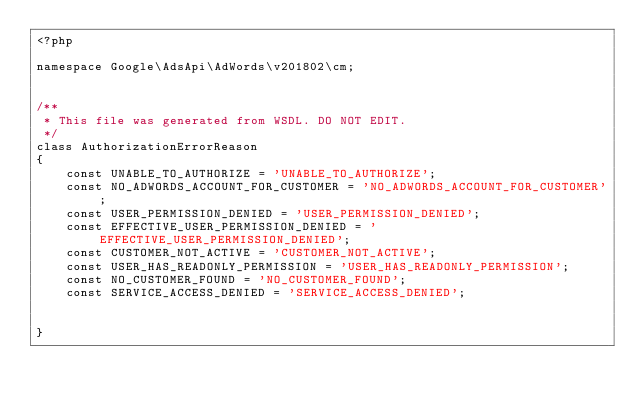<code> <loc_0><loc_0><loc_500><loc_500><_PHP_><?php

namespace Google\AdsApi\AdWords\v201802\cm;


/**
 * This file was generated from WSDL. DO NOT EDIT.
 */
class AuthorizationErrorReason
{
    const UNABLE_TO_AUTHORIZE = 'UNABLE_TO_AUTHORIZE';
    const NO_ADWORDS_ACCOUNT_FOR_CUSTOMER = 'NO_ADWORDS_ACCOUNT_FOR_CUSTOMER';
    const USER_PERMISSION_DENIED = 'USER_PERMISSION_DENIED';
    const EFFECTIVE_USER_PERMISSION_DENIED = 'EFFECTIVE_USER_PERMISSION_DENIED';
    const CUSTOMER_NOT_ACTIVE = 'CUSTOMER_NOT_ACTIVE';
    const USER_HAS_READONLY_PERMISSION = 'USER_HAS_READONLY_PERMISSION';
    const NO_CUSTOMER_FOUND = 'NO_CUSTOMER_FOUND';
    const SERVICE_ACCESS_DENIED = 'SERVICE_ACCESS_DENIED';


}
</code> 